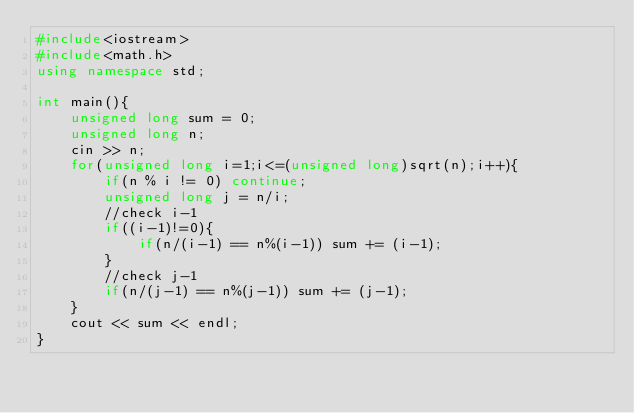Convert code to text. <code><loc_0><loc_0><loc_500><loc_500><_C++_>#include<iostream>
#include<math.h>
using namespace std;

int main(){
	unsigned long sum = 0;
	unsigned long n;
	cin >> n;
	for(unsigned long i=1;i<=(unsigned long)sqrt(n);i++){
		if(n % i != 0) continue;
		unsigned long j = n/i;
		//check i-1
		if((i-1)!=0){
			if(n/(i-1) == n%(i-1)) sum += (i-1);
		}
		//check j-1
		if(n/(j-1) == n%(j-1)) sum += (j-1);
	}
	cout << sum << endl;
}
</code> 